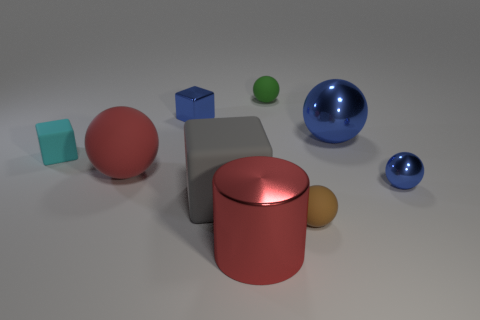Subtract all red balls. How many balls are left? 4 Subtract all gray matte blocks. How many blocks are left? 2 Subtract 0 brown cylinders. How many objects are left? 9 Subtract all cubes. How many objects are left? 6 Subtract 1 balls. How many balls are left? 4 Subtract all red blocks. Subtract all green cylinders. How many blocks are left? 3 Subtract all yellow balls. How many blue blocks are left? 1 Subtract all tiny rubber cylinders. Subtract all big gray things. How many objects are left? 8 Add 2 red objects. How many red objects are left? 4 Add 3 gray matte things. How many gray matte things exist? 4 